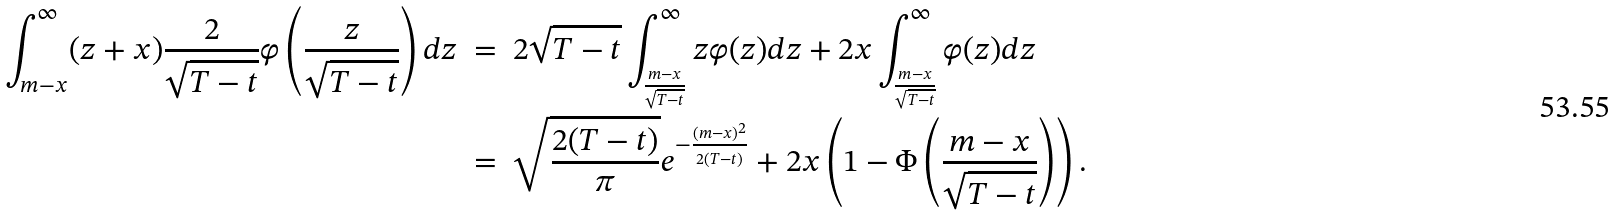<formula> <loc_0><loc_0><loc_500><loc_500>\int _ { m - x } ^ { \infty } ( z + x ) \frac { 2 } { \sqrt { T - t } } \varphi \left ( \frac { z } { \sqrt { T - t } } \right ) d z \ & = \ 2 \sqrt { T - t } \int _ { \frac { m - x } { \sqrt { T - t } } } ^ { \infty } z \varphi ( z ) d z + 2 x \int _ { \frac { m - x } { \sqrt { T - t } } } ^ { \infty } \varphi ( z ) d z \\ & = \ \sqrt { \frac { 2 ( T - t ) } { \pi } } e ^ { - \frac { ( m - x ) ^ { 2 } } { 2 ( T - t ) } } + 2 x \left ( 1 - \Phi \left ( \frac { m - x } { \sqrt { T - t } } \right ) \right ) .</formula> 